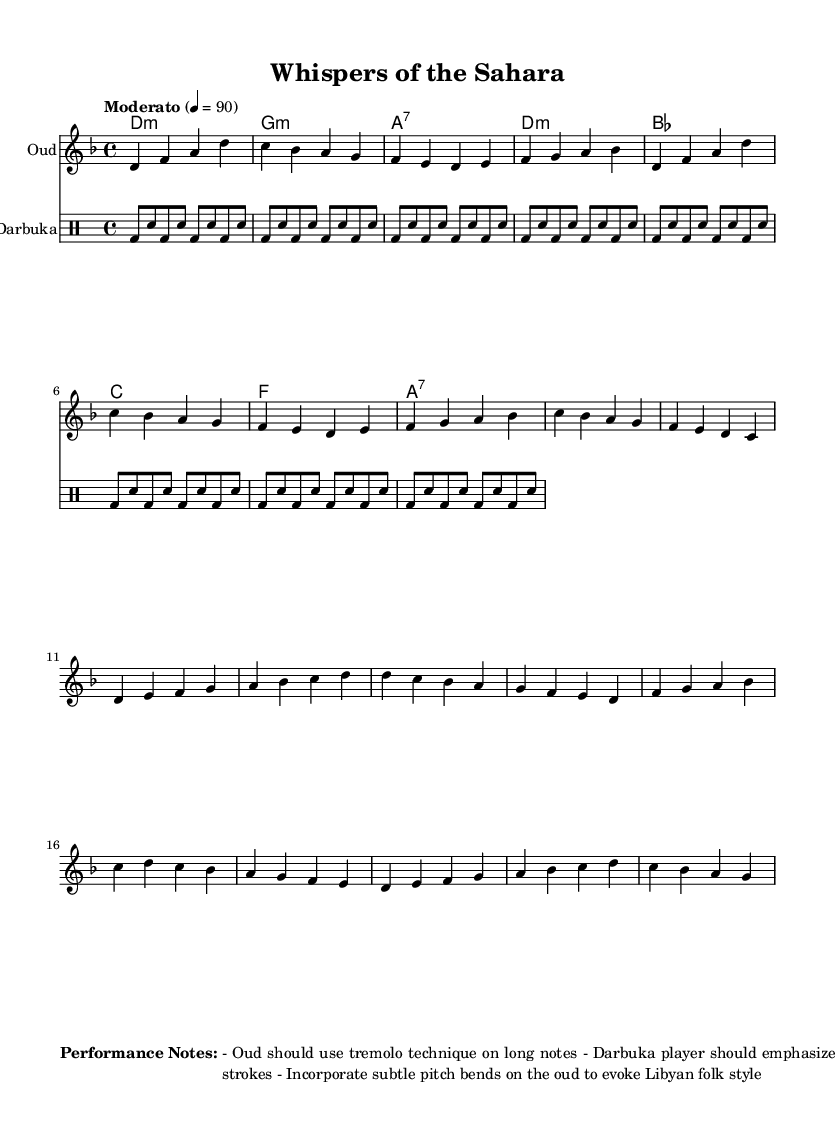What is the key signature of this music? The key signature is D minor, which has one flat (B flat). This can be determined by the indication found at the beginning of the staff, marked by the "key d \minor."
Answer: D minor What is the time signature of this music? The time signature is 4/4, which means there are four beats per measure and each quarter note gets one beat. This is indicated at the start of the piece with the notation "4/4."
Answer: 4/4 What is the tempo marking for this piece? The tempo marking is "Moderato" with a metronome marking of 90 beats per minute. This is noted in the tempo indication written at the beginning of the score as “Moderato” 4 = 90.
Answer: Moderato 4 = 90 How many measures are there in the Chorus section? There are four measures in the Chorus section. This can be identified by counting the individual measures during the Chorus part of the oud melody and darabuka rhythm, which is distinctly separated from the Verse prior to it.
Answer: 4 measures What type of drum pattern does the darbuka use in this piece? The darbuka uses a rhythm that alternates between 'Dum' (bass) and 'Sn' (splash) strokes, indicating a traditional Middle Eastern drumming style. This can be observed in the drummode section, where the notation repeatedly features text patterns of 'bd' (Dum) and 'sn' (Sn) throughout.
Answer: Dum and Sn What performance technique is suggested for the oud on long notes? The performance technique suggested for the oud on long notes is tremolo. This is mentioned specifically in the performance notes that accompany the music, emphasizing an expressive playing style.
Answer: Tremolo How should the darbuka player emphasize the strokes? The darbuka player should emphasize the 'Dum' (D) strokes. This is described in the performance notes that give guidance on how the darbuka should be played within the context of the piece, ensuring the distinct sound is highlighted.
Answer: Dum 